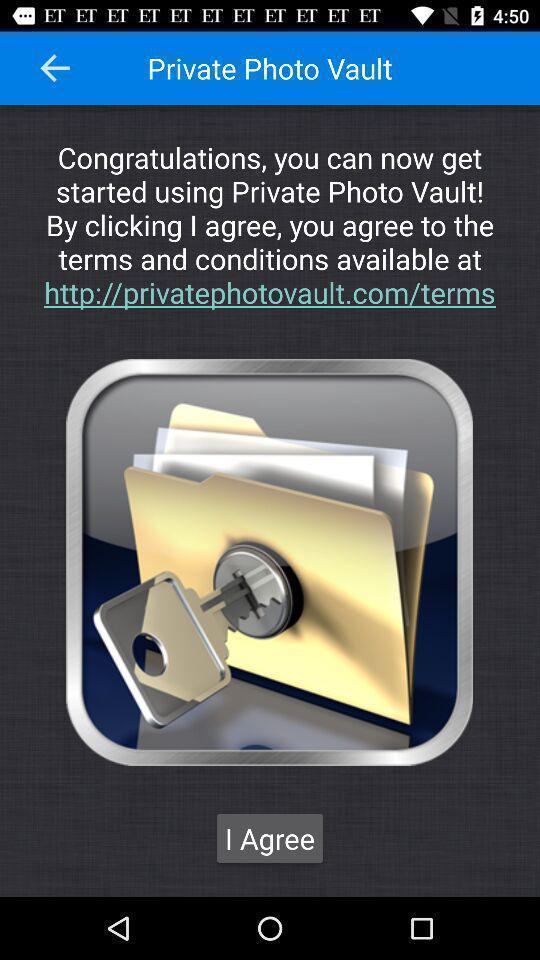Tell me about the visual elements in this screen capture. Screen shows terms and conditions. 